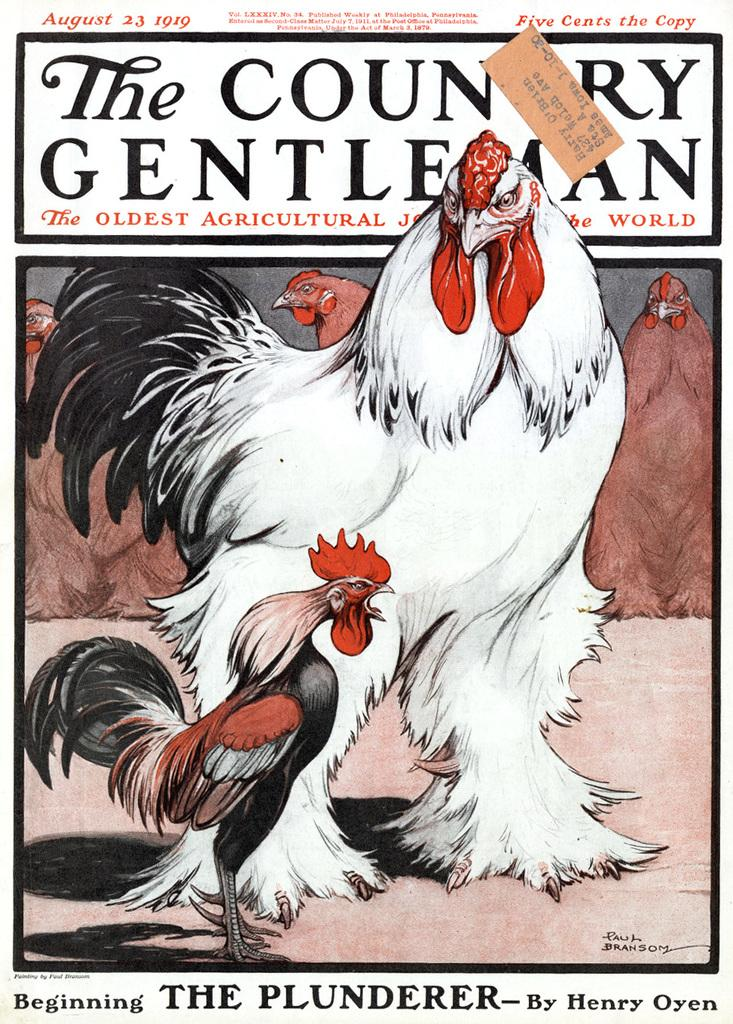What is the main subject of the image? The main subject of the image is a poster. What type of animals are depicted on the poster? The poster contains drawings of cocks and hens. Is there any text present on the image? Yes, there is text written on the image. What type of map can be seen in the image? There is no map present in the image; it features a poster with drawings of cocks and hens and text. 